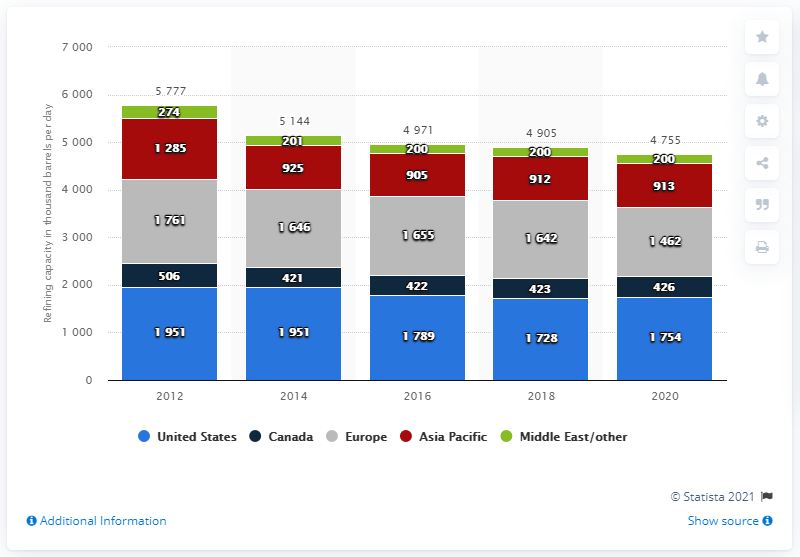Point out several critical features in this image. ExxonMobil's refinery capacity is primarily located in the United States. 